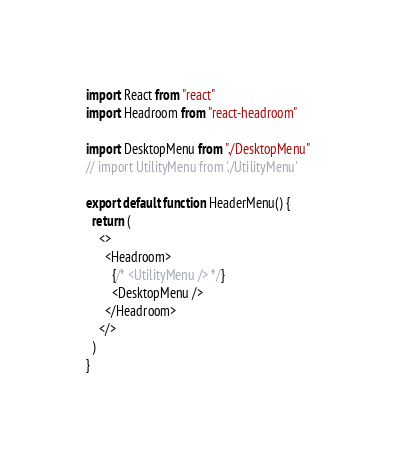Convert code to text. <code><loc_0><loc_0><loc_500><loc_500><_TypeScript_>import React from "react"
import Headroom from "react-headroom"

import DesktopMenu from "./DesktopMenu"
// import UtilityMenu from './UtilityMenu'

export default function HeaderMenu() {
  return (
    <>
      <Headroom>
        {/* <UtilityMenu /> */}
        <DesktopMenu />
      </Headroom>
    </>
  )
}
</code> 